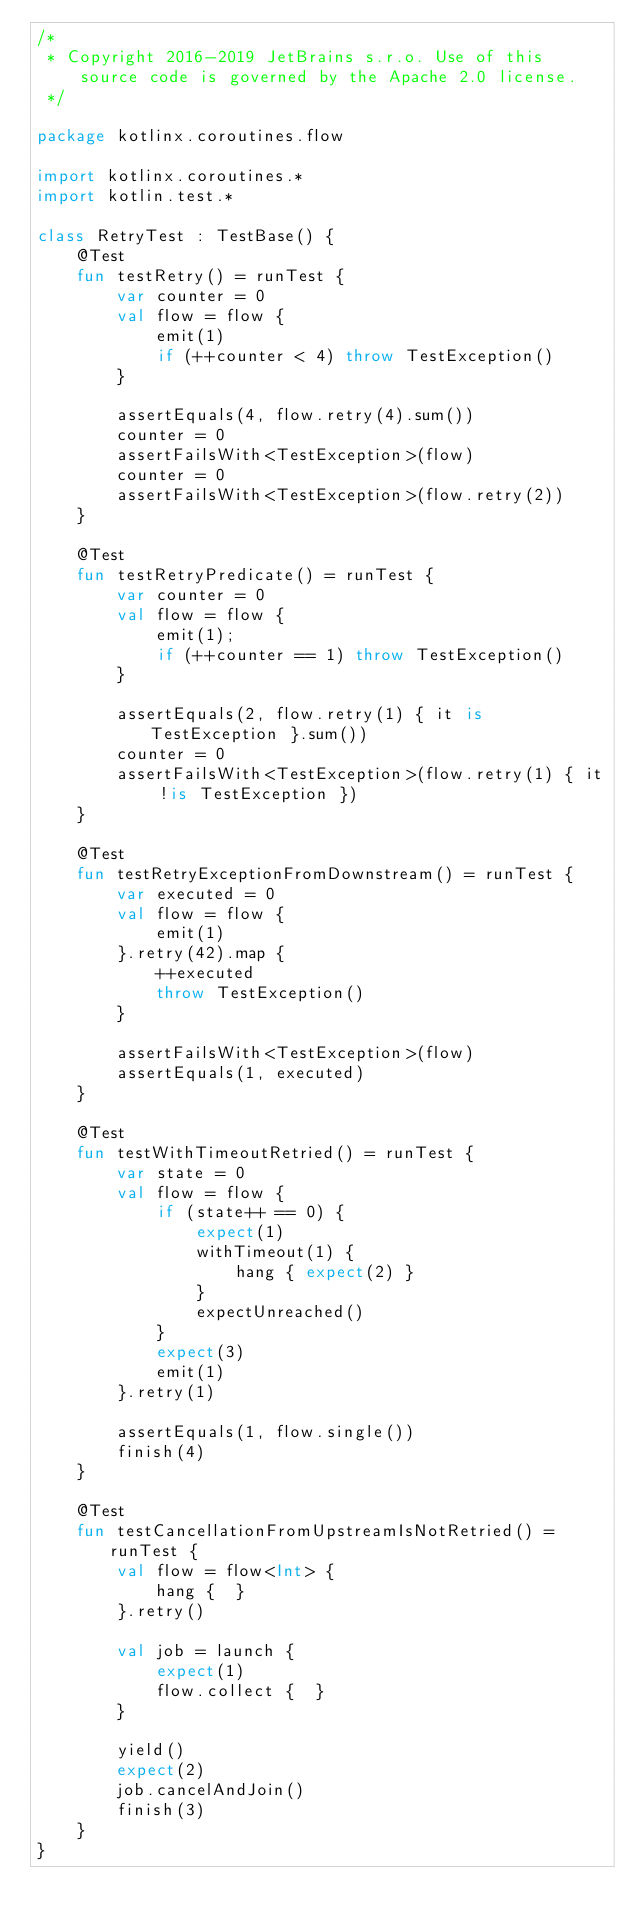<code> <loc_0><loc_0><loc_500><loc_500><_Kotlin_>/*
 * Copyright 2016-2019 JetBrains s.r.o. Use of this source code is governed by the Apache 2.0 license.
 */

package kotlinx.coroutines.flow

import kotlinx.coroutines.*
import kotlin.test.*

class RetryTest : TestBase() {
    @Test
    fun testRetry() = runTest {
        var counter = 0
        val flow = flow {
            emit(1)
            if (++counter < 4) throw TestException()
        }

        assertEquals(4, flow.retry(4).sum())
        counter = 0
        assertFailsWith<TestException>(flow)
        counter = 0
        assertFailsWith<TestException>(flow.retry(2))
    }

    @Test
    fun testRetryPredicate() = runTest {
        var counter = 0
        val flow = flow {
            emit(1);
            if (++counter == 1) throw TestException()
        }

        assertEquals(2, flow.retry(1) { it is TestException }.sum())
        counter = 0
        assertFailsWith<TestException>(flow.retry(1) { it !is TestException })
    }

    @Test
    fun testRetryExceptionFromDownstream() = runTest {
        var executed = 0
        val flow = flow {
            emit(1)
        }.retry(42).map {
            ++executed
            throw TestException()
        }

        assertFailsWith<TestException>(flow)
        assertEquals(1, executed)
    }

    @Test
    fun testWithTimeoutRetried() = runTest {
        var state = 0
        val flow = flow {
            if (state++ == 0) {
                expect(1)
                withTimeout(1) {
                    hang { expect(2) }
                }
                expectUnreached()
            }
            expect(3)
            emit(1)
        }.retry(1)

        assertEquals(1, flow.single())
        finish(4)
    }

    @Test
    fun testCancellationFromUpstreamIsNotRetried() = runTest {
        val flow = flow<Int> {
            hang {  }
        }.retry()

        val job = launch {
            expect(1)
            flow.collect {  }
        }

        yield()
        expect(2)
        job.cancelAndJoin()
        finish(3)
    }
}</code> 